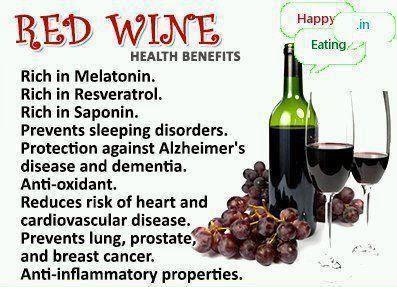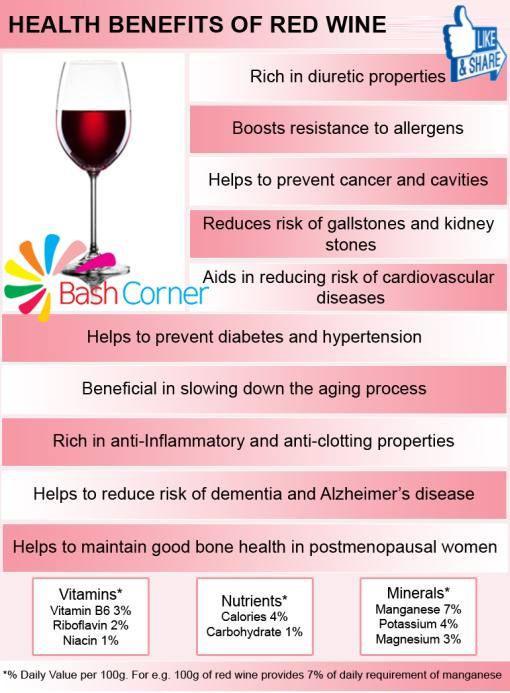The first image is the image on the left, the second image is the image on the right. Considering the images on both sides, is "Images show a total of three wine bottles." valid? Answer yes or no. No. 